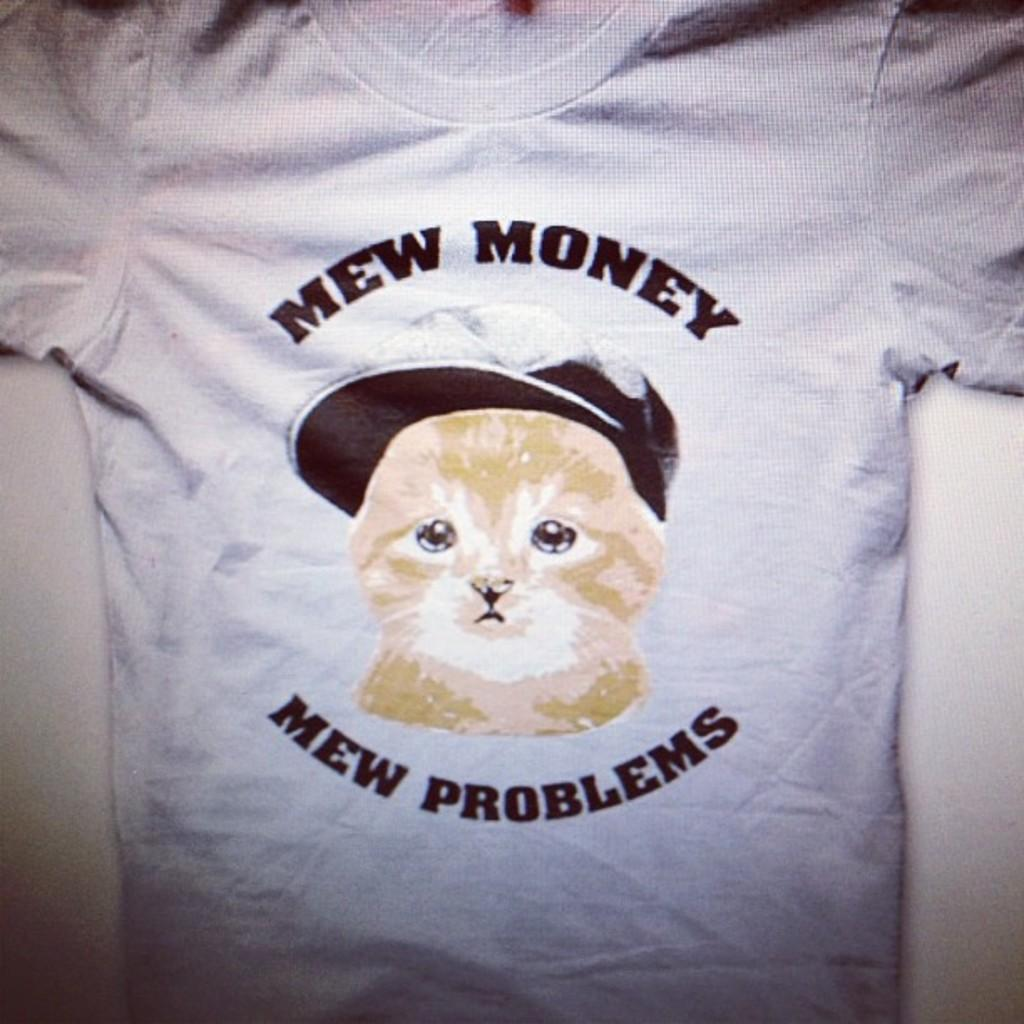What type of clothing item is visible in the image? There is a T-shirt in the image. What is depicted on the T-shirt? There is a picture printed on the T-shirt. Are there any words or phrases printed on the T-shirt? Yes, there is text printed on the T-shirt. Can you describe the woman touching the loss in the image? There is no woman or loss present in the image; it only features a T-shirt with a picture and text printed on it. 